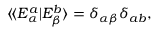<formula> <loc_0><loc_0><loc_500><loc_500>\begin{array} { r } { \langle \, \langle E _ { \alpha } ^ { a } | E _ { \beta } ^ { b } \rangle = \delta _ { \alpha \beta } \delta _ { a b } , } \end{array}</formula> 